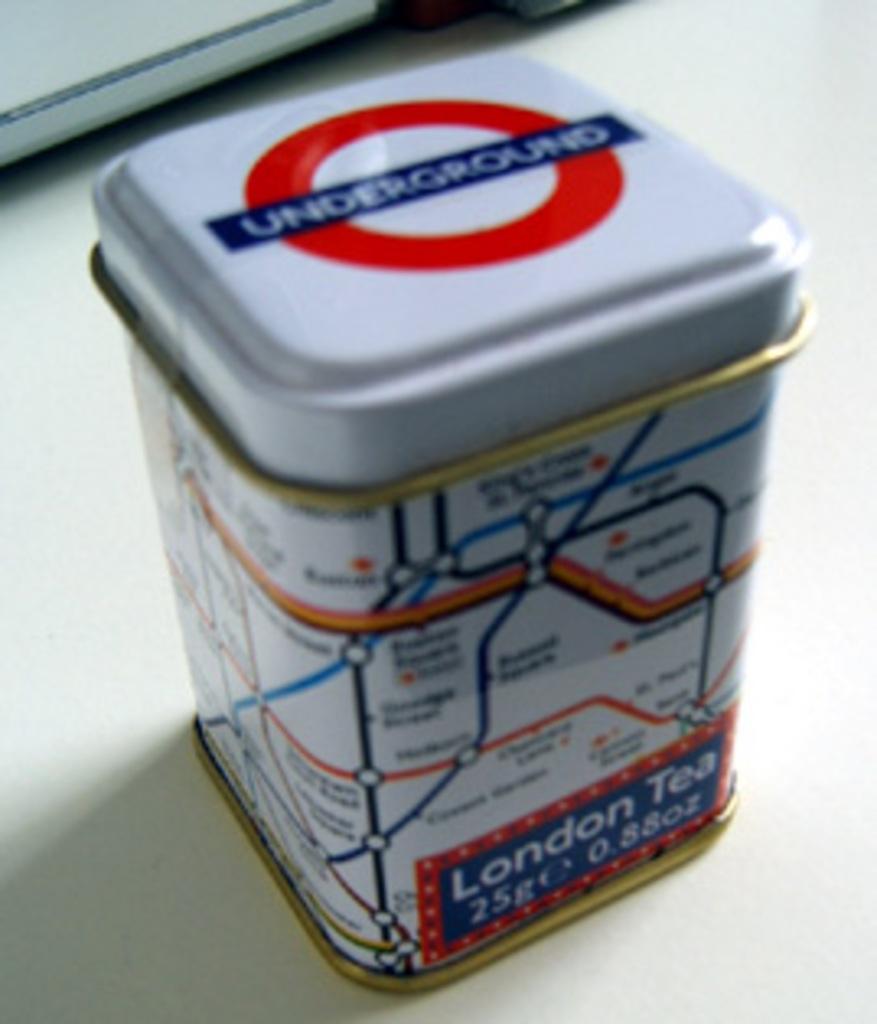What kind of tea?
Your answer should be compact. London. 